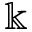<formula> <loc_0><loc_0><loc_500><loc_500>\ B b b k</formula> 